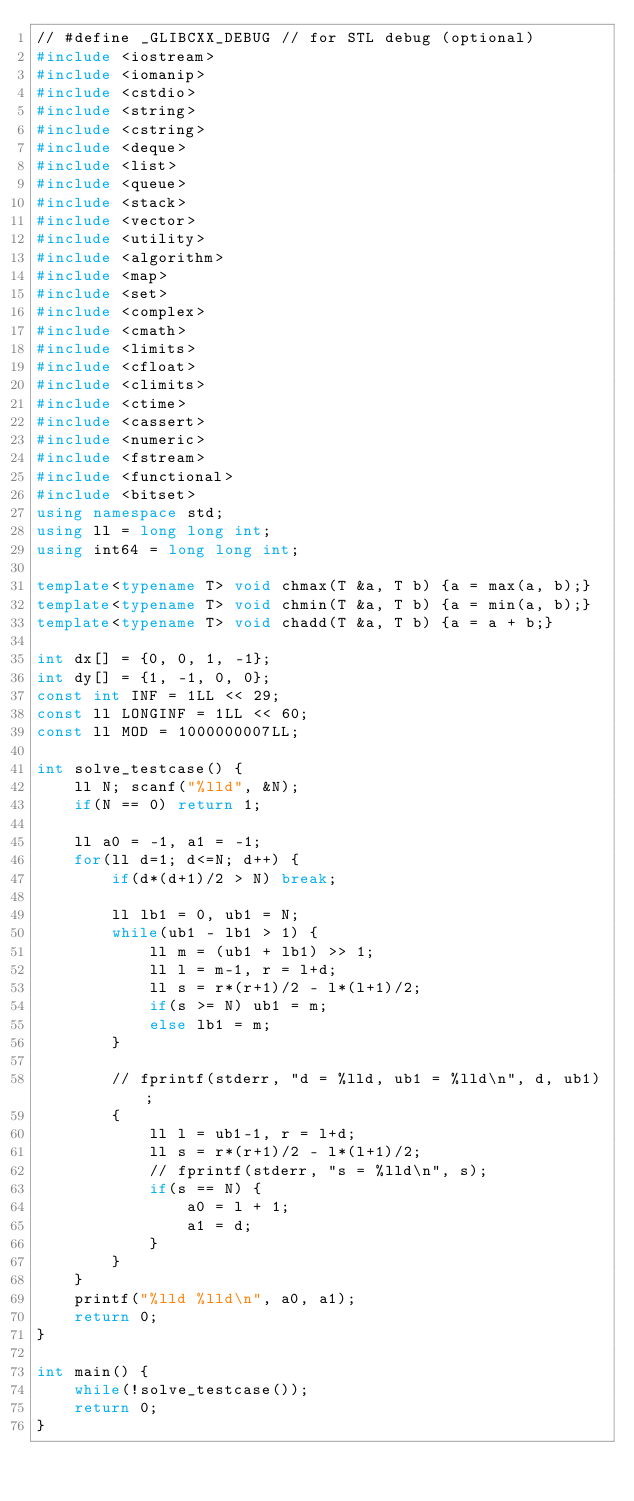Convert code to text. <code><loc_0><loc_0><loc_500><loc_500><_C++_>// #define _GLIBCXX_DEBUG // for STL debug (optional)
#include <iostream>
#include <iomanip>
#include <cstdio>
#include <string>
#include <cstring>
#include <deque>
#include <list>
#include <queue>
#include <stack>
#include <vector>
#include <utility>
#include <algorithm>
#include <map>
#include <set>
#include <complex>
#include <cmath>
#include <limits>
#include <cfloat>
#include <climits>
#include <ctime>
#include <cassert>
#include <numeric>
#include <fstream>
#include <functional>
#include <bitset>
using namespace std;
using ll = long long int;
using int64 = long long int;
 
template<typename T> void chmax(T &a, T b) {a = max(a, b);}
template<typename T> void chmin(T &a, T b) {a = min(a, b);}
template<typename T> void chadd(T &a, T b) {a = a + b;}
 
int dx[] = {0, 0, 1, -1};
int dy[] = {1, -1, 0, 0};
const int INF = 1LL << 29;
const ll LONGINF = 1LL << 60;
const ll MOD = 1000000007LL;

int solve_testcase() {
    ll N; scanf("%lld", &N);
    if(N == 0) return 1;
    
    ll a0 = -1, a1 = -1;
    for(ll d=1; d<=N; d++) {
        if(d*(d+1)/2 > N) break;

        ll lb1 = 0, ub1 = N;
        while(ub1 - lb1 > 1) {
            ll m = (ub1 + lb1) >> 1;
            ll l = m-1, r = l+d;
            ll s = r*(r+1)/2 - l*(l+1)/2;
            if(s >= N) ub1 = m;
            else lb1 = m;
        }

        // fprintf(stderr, "d = %lld, ub1 = %lld\n", d, ub1);
        {
            ll l = ub1-1, r = l+d;
            ll s = r*(r+1)/2 - l*(l+1)/2;
            // fprintf(stderr, "s = %lld\n", s);
            if(s == N) {
                a0 = l + 1;
                a1 = d;
            }
        }
    }
    printf("%lld %lld\n", a0, a1);
    return 0;
}

int main() {
    while(!solve_testcase());
    return 0;
}

</code> 